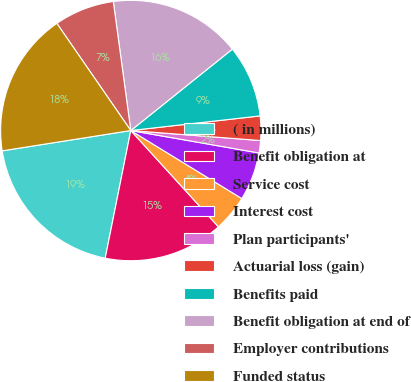<chart> <loc_0><loc_0><loc_500><loc_500><pie_chart><fcel>( in millions)<fcel>Benefit obligation at<fcel>Service cost<fcel>Interest cost<fcel>Plan participants'<fcel>Actuarial loss (gain)<fcel>Benefits paid<fcel>Benefit obligation at end of<fcel>Employer contributions<fcel>Funded status<nl><fcel>19.36%<fcel>14.9%<fcel>4.5%<fcel>5.99%<fcel>1.53%<fcel>3.02%<fcel>8.96%<fcel>16.39%<fcel>7.47%<fcel>17.88%<nl></chart> 